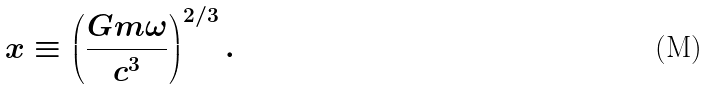<formula> <loc_0><loc_0><loc_500><loc_500>x \equiv \left ( \frac { G m \omega } { c ^ { 3 } } \right ) ^ { 2 / 3 } .</formula> 